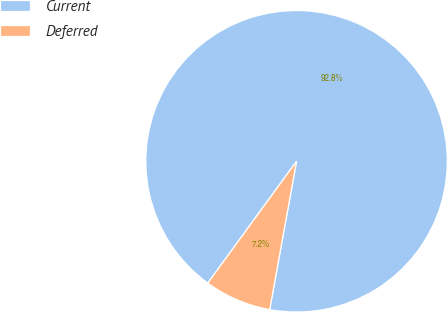Convert chart to OTSL. <chart><loc_0><loc_0><loc_500><loc_500><pie_chart><fcel>Current<fcel>Deferred<nl><fcel>92.83%<fcel>7.17%<nl></chart> 